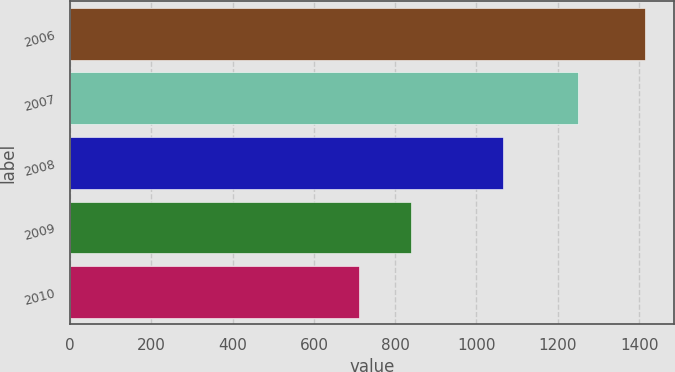<chart> <loc_0><loc_0><loc_500><loc_500><bar_chart><fcel>2006<fcel>2007<fcel>2008<fcel>2009<fcel>2010<nl><fcel>1414<fcel>1249<fcel>1064<fcel>839<fcel>711<nl></chart> 